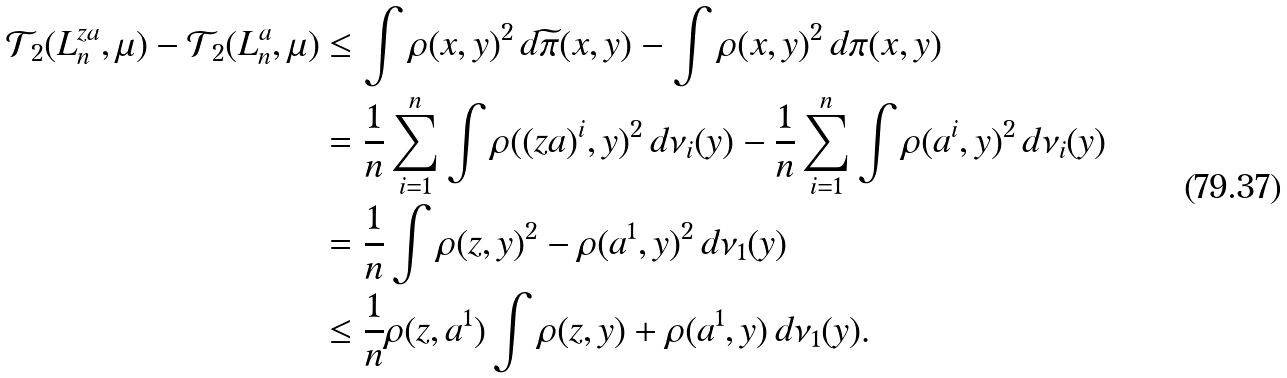<formula> <loc_0><loc_0><loc_500><loc_500>\mathcal { T } _ { 2 } ( L _ { n } ^ { z a } , \mu ) - \mathcal { T } _ { 2 } ( L _ { n } ^ { a } , \mu ) & \leq \int \rho ( x , y ) ^ { 2 } \, d \widetilde { \pi } ( x , y ) - \int \rho ( x , y ) ^ { 2 } \, d \pi ( x , y ) \\ & = \frac { 1 } { n } \sum _ { i = 1 } ^ { n } \int \rho ( ( z a ) ^ { i } , y ) ^ { 2 } \, d \nu _ { i } ( y ) - \frac { 1 } { n } \sum _ { i = 1 } ^ { n } \int \rho ( a ^ { i } , y ) ^ { 2 } \, d \nu _ { i } ( y ) \\ & = \frac { 1 } { n } \int \rho ( z , y ) ^ { 2 } - \rho ( a ^ { 1 } , y ) ^ { 2 } \, d \nu _ { 1 } ( y ) \\ & \leq \frac { 1 } { n } \rho ( z , a ^ { 1 } ) \int \rho ( z , y ) + \rho ( a ^ { 1 } , y ) \, d \nu _ { 1 } ( y ) .</formula> 